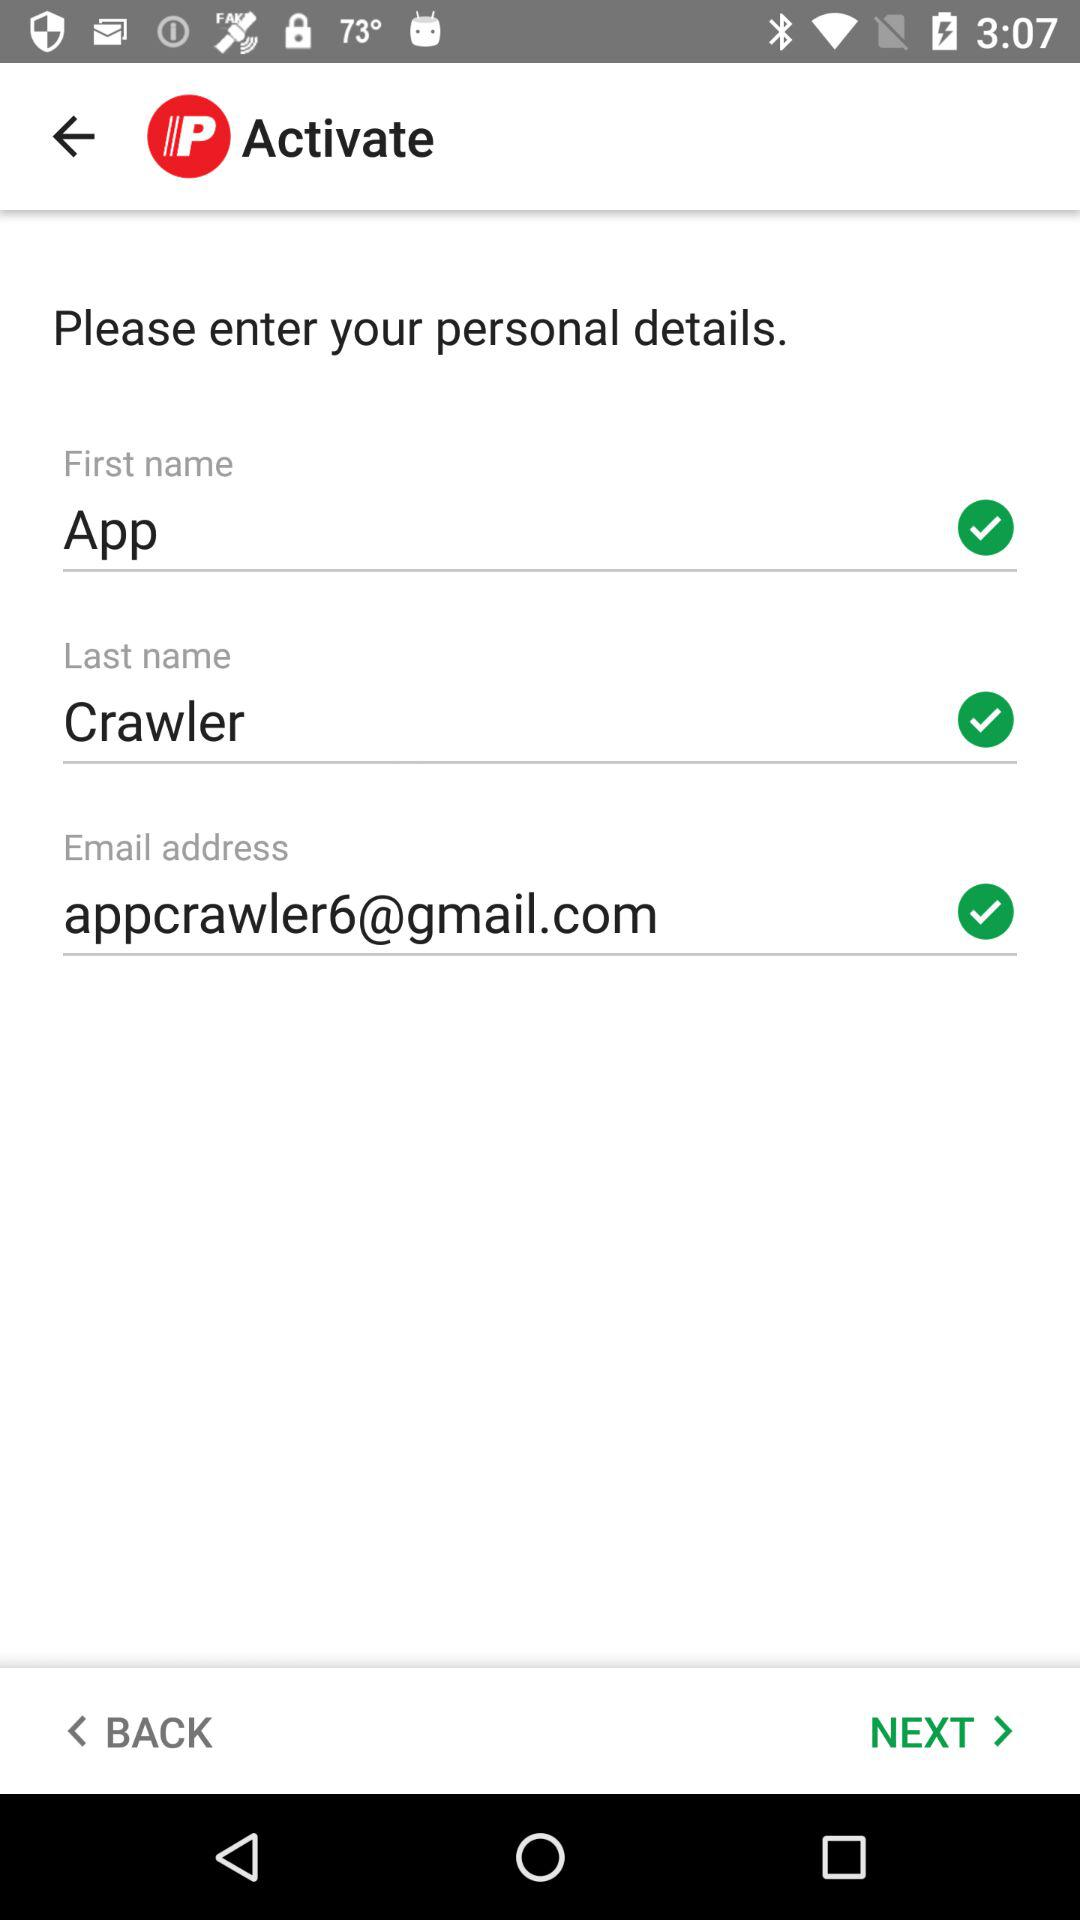What is the last name of the user? The last name of the user is Crawler. 